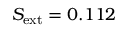Convert formula to latex. <formula><loc_0><loc_0><loc_500><loc_500>S _ { e x t } = 0 . 1 1 2</formula> 